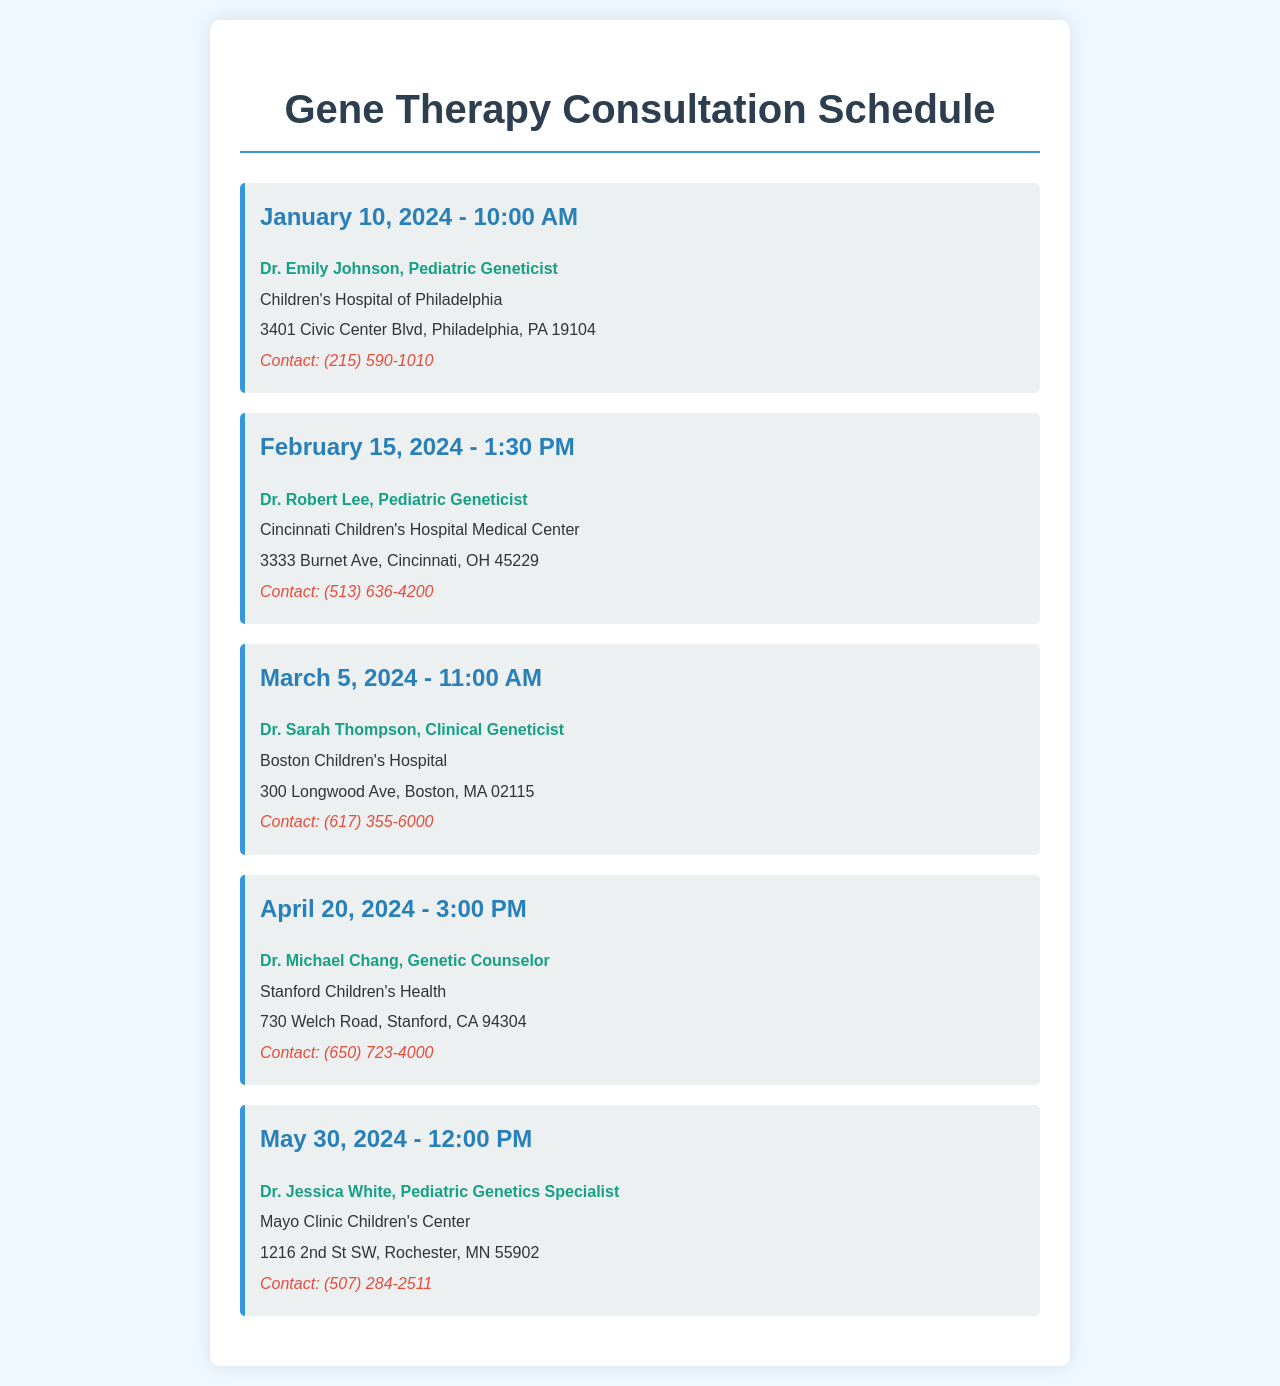What is the date of the first appointment? The first appointment is scheduled for January 10, 2024, as listed in the document.
Answer: January 10, 2024 Who is the specialist for the April appointment? The specialist for the April 20, 2024 appointment is Dr. Michael Chang, Genetic Counselor.
Answer: Dr. Michael Chang What time is the consultation on May 30, 2024? The consultation on May 30, 2024 is at 12:00 PM, as mentioned in the schedule.
Answer: 12:00 PM How many pediatric genetic specialists are listed in the document? There are five pediatric genetic specialists listed in the appointment schedule.
Answer: Five Which hospital is associated with Dr. Sarah Thompson? Dr. Sarah Thompson is associated with Boston Children's Hospital.
Answer: Boston Children's Hospital What is the contact number for Cincinnati Children's Hospital? The contact number for Cincinnati Children's Hospital is (513) 636-4200, provided in the document.
Answer: (513) 636-4200 What city is Children's Hospital of Philadelphia located in? Children's Hospital of Philadelphia is located in Philadelphia, PA.
Answer: Philadelphia Which appointment is scheduled last in the document? The last appointment is scheduled for May 30, 2024, as the appointments are listed in chronological order.
Answer: May 30, 2024 